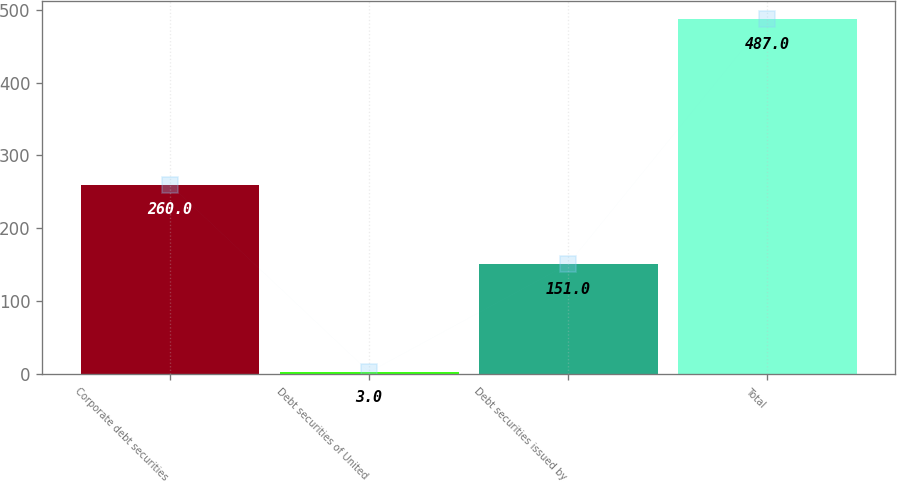Convert chart. <chart><loc_0><loc_0><loc_500><loc_500><bar_chart><fcel>Corporate debt securities<fcel>Debt securities of United<fcel>Debt securities issued by<fcel>Total<nl><fcel>260<fcel>3<fcel>151<fcel>487<nl></chart> 